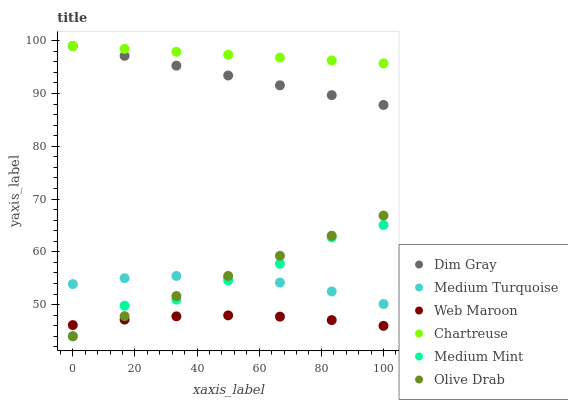Does Web Maroon have the minimum area under the curve?
Answer yes or no. Yes. Does Chartreuse have the maximum area under the curve?
Answer yes or no. Yes. Does Dim Gray have the minimum area under the curve?
Answer yes or no. No. Does Dim Gray have the maximum area under the curve?
Answer yes or no. No. Is Dim Gray the smoothest?
Answer yes or no. Yes. Is Medium Mint the roughest?
Answer yes or no. Yes. Is Web Maroon the smoothest?
Answer yes or no. No. Is Web Maroon the roughest?
Answer yes or no. No. Does Medium Mint have the lowest value?
Answer yes or no. Yes. Does Dim Gray have the lowest value?
Answer yes or no. No. Does Chartreuse have the highest value?
Answer yes or no. Yes. Does Web Maroon have the highest value?
Answer yes or no. No. Is Medium Turquoise less than Chartreuse?
Answer yes or no. Yes. Is Chartreuse greater than Web Maroon?
Answer yes or no. Yes. Does Web Maroon intersect Medium Mint?
Answer yes or no. Yes. Is Web Maroon less than Medium Mint?
Answer yes or no. No. Is Web Maroon greater than Medium Mint?
Answer yes or no. No. Does Medium Turquoise intersect Chartreuse?
Answer yes or no. No. 